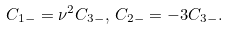Convert formula to latex. <formula><loc_0><loc_0><loc_500><loc_500>C _ { 1 - } = \nu ^ { 2 } C _ { 3 - } , \, C _ { 2 - } = - 3 C _ { 3 - } .</formula> 